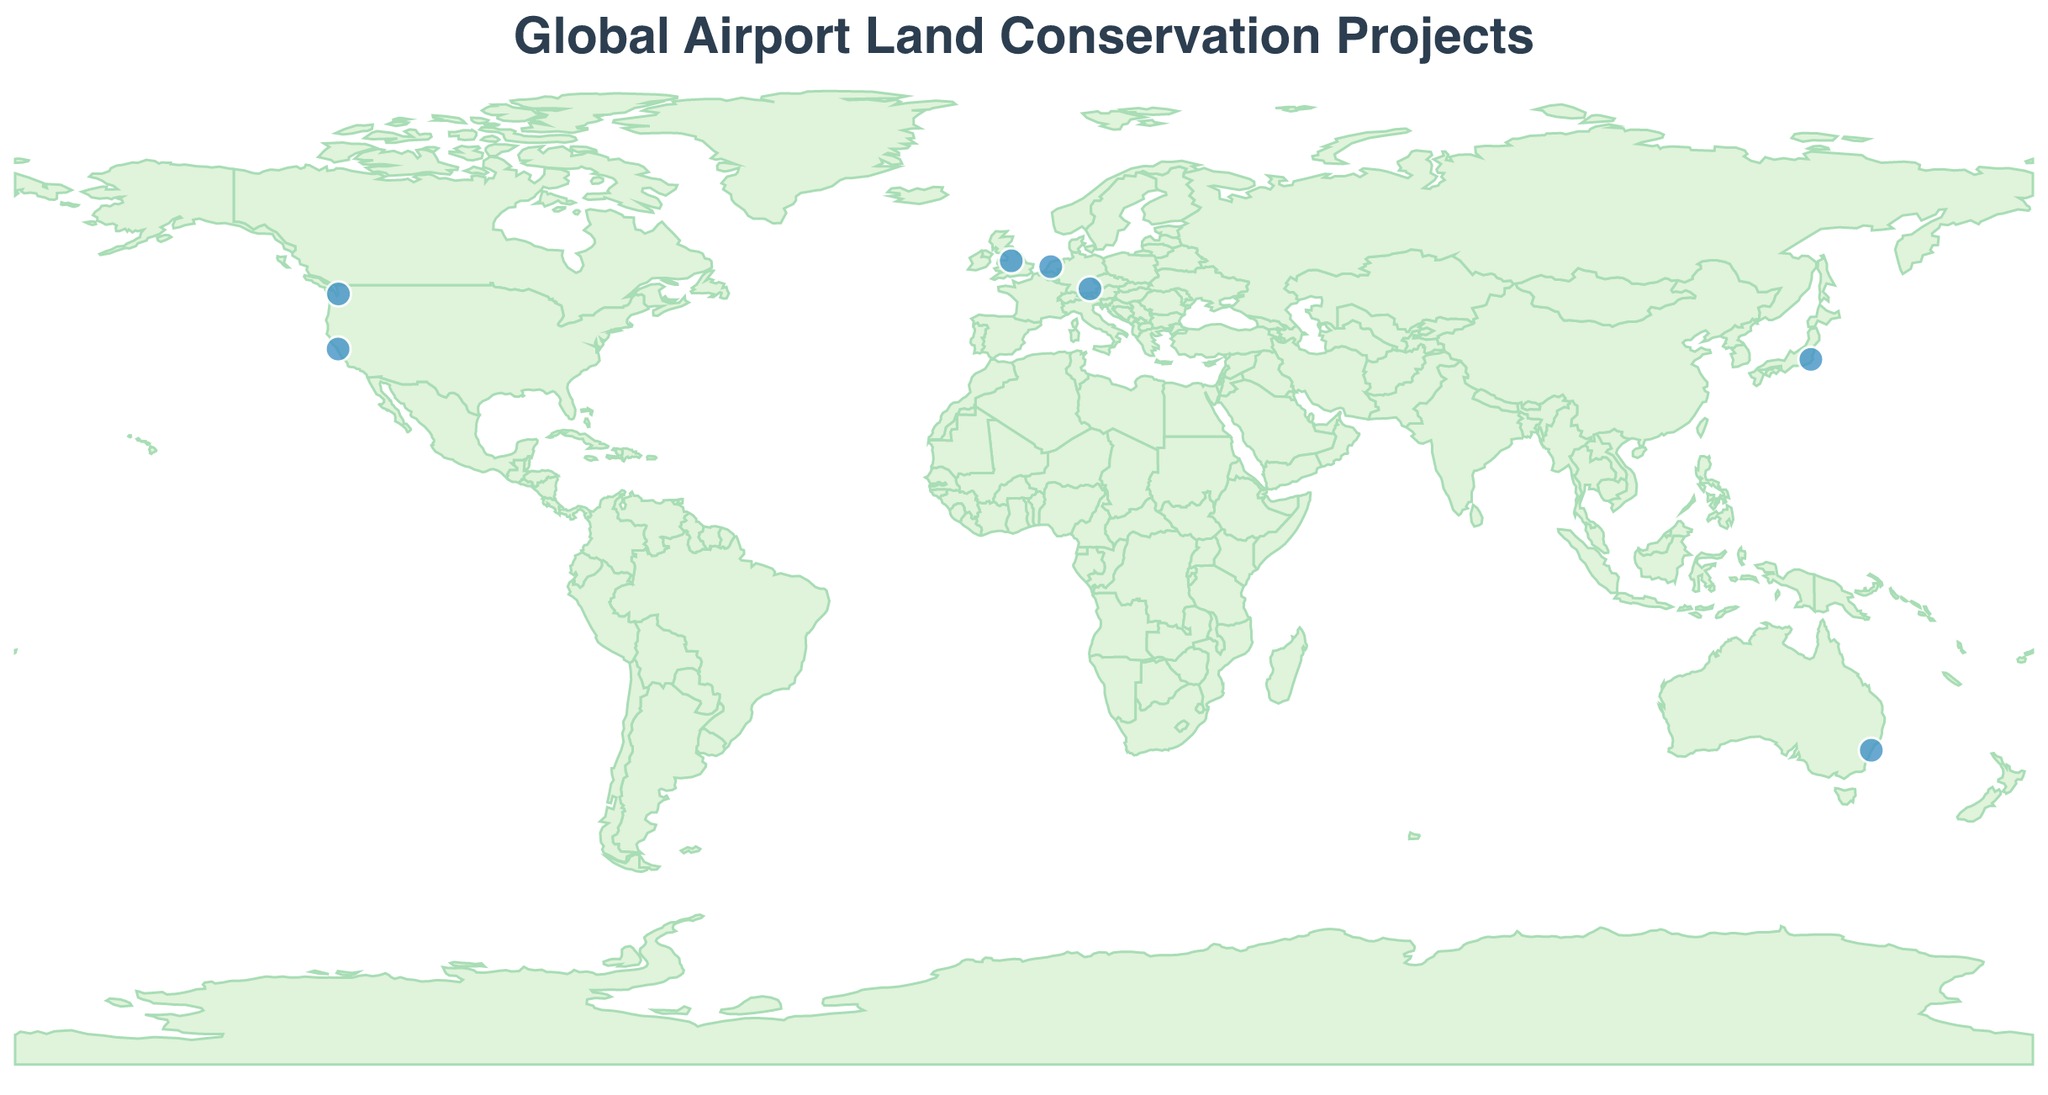What is the title of the figure? The title can be found at the top of the figure, which is usually in larger font size and bold to draw attention.
Answer: Global Airport Land Conservation Projects How many conservation projects are shown in the figure? By observing the number of distinct data points (circles) on the map, we can count the total number of projects.
Answer: 7 Which airport's conservation project focuses on carbon sequestration and noise reduction through reforestation? By examining the tooltip information when hovering over the data points on the map, we can find the details for each conservation project. The project focusing on carbon sequestration and noise reduction is linked to Amsterdam Airport Schiphol.
Answer: Amsterdam Airport Schiphol Among the airports listed, which country has the most conservation projects mentioned? By reviewing the list of airports and their respective countries, we can count the number of projects for each country. USA has two projects: one in San Francisco and one in Seattle.
Answer: USA Which conservation project supports the highest number of bird species? By comparing the "EcologicalImpact" descriptions of each project, we can identify that the Munich Airport's "Erdinger Moos Preservation" project supports 180 bird species, which is the highest.
Answer: Erdinger Moos Preservation Which airport's conservation project aims at preserving native flora and firefly breeding grounds? Analyzing the tooltip information, we can find the details for each airport's conservation project. The project aiming at preserving native flora and firefly breeding grounds is related to Narita International Airport.
Answer: Narita International Airport What is the primary conservation focus of the project at San Francisco International Airport? By hovering over the data point representing San Francisco International Airport and reading the tooltip information, we can determine that the primary focus is on protecting habitat for the endangered San Francisco garter snake.
Answer: Protected habitat for endangered San Francisco garter snake How many different countries are involved in the conservation projects shown on the map? By enumerating the distinct countries from the listed airports, we can count a total of 6 distinct countries (United Kingdom, USA, Germany, Australia, Japan, Netherlands).
Answer: 6 Compare the latitude of Munich Airport and Sydney Airport; which one is located further north? Observing the latitude values of Munich Airport (48.3537) and Sydney Airport (-33.9399), we note that positive latitudes indicate northern hemisphere locations. Therefore, Munich Airport is further north.
Answer: Munich Airport Which conservation project is associated with salmon habitat improvement and water quality enhancement? By reading the tooltip information, we can identify the "Miller Creek Restoration" project linked to Seattle-Tacoma International Airport as the one focused on salmon habitat improvement and water quality enhancement.
Answer: Miller Creek Restoration 